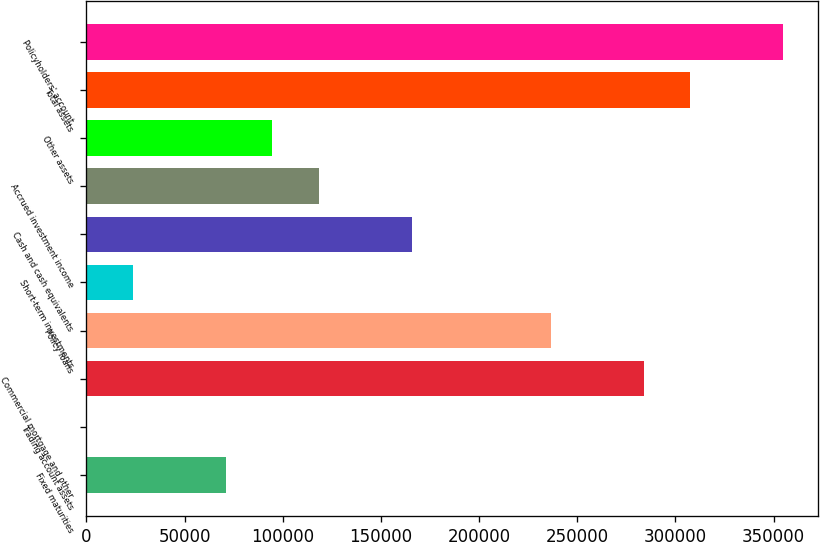Convert chart. <chart><loc_0><loc_0><loc_500><loc_500><bar_chart><fcel>Fixed maturities<fcel>Trading account assets<fcel>Commercial mortgage and other<fcel>Policy loans<fcel>Short-term investments<fcel>Cash and cash equivalents<fcel>Accrued investment income<fcel>Other assets<fcel>Total assets<fcel>Policyholders' account<nl><fcel>71101.8<fcel>150<fcel>283957<fcel>236656<fcel>23800.6<fcel>165704<fcel>118403<fcel>94752.4<fcel>307608<fcel>354909<nl></chart> 